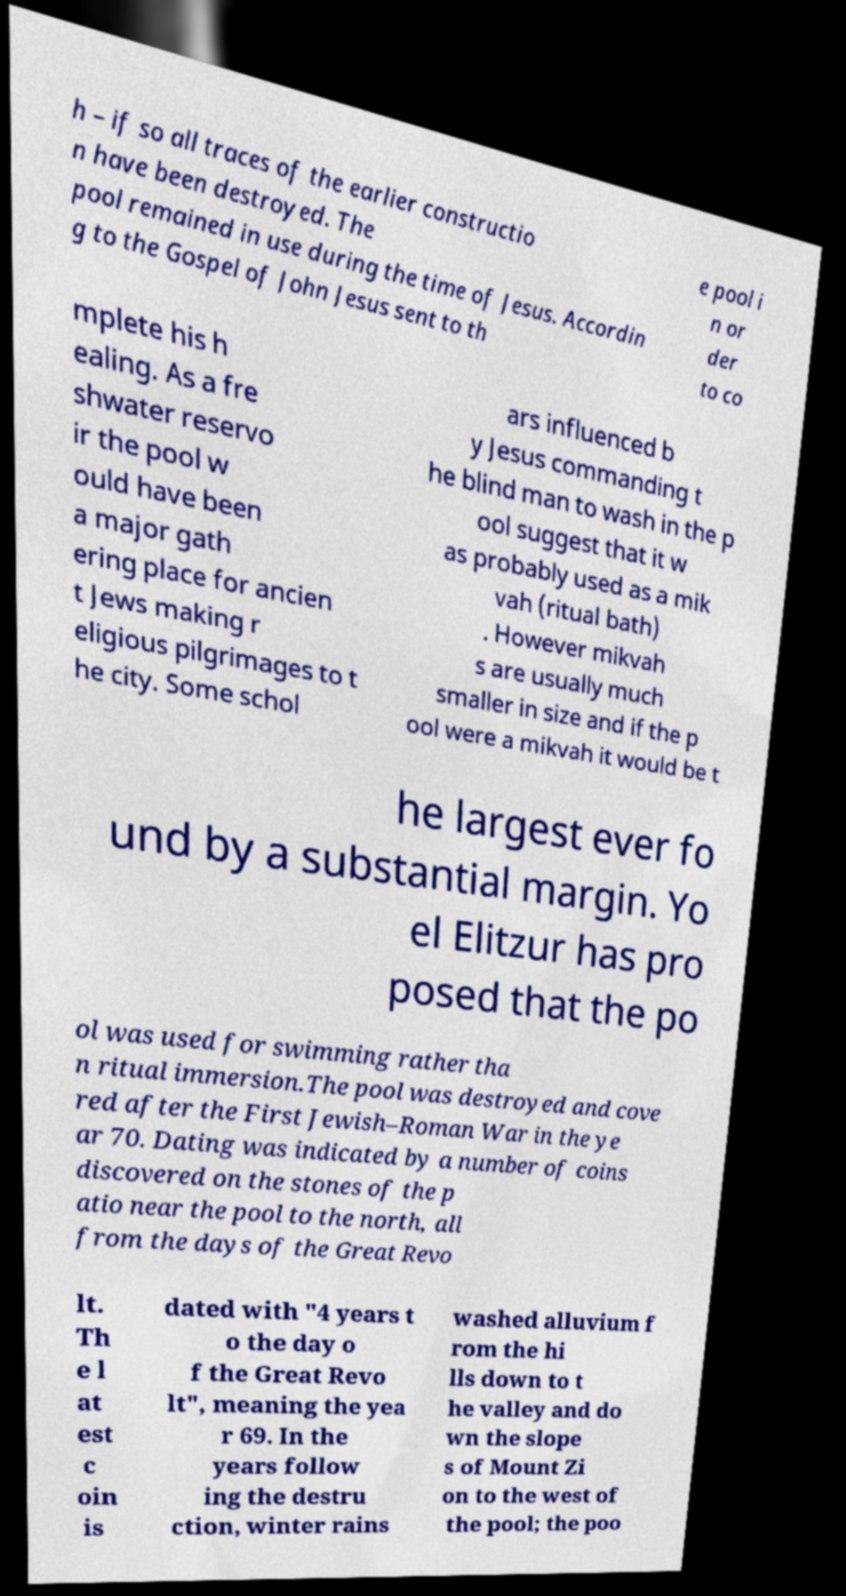I need the written content from this picture converted into text. Can you do that? h – if so all traces of the earlier constructio n have been destroyed. The pool remained in use during the time of Jesus. Accordin g to the Gospel of John Jesus sent to th e pool i n or der to co mplete his h ealing. As a fre shwater reservo ir the pool w ould have been a major gath ering place for ancien t Jews making r eligious pilgrimages to t he city. Some schol ars influenced b y Jesus commanding t he blind man to wash in the p ool suggest that it w as probably used as a mik vah (ritual bath) . However mikvah s are usually much smaller in size and if the p ool were a mikvah it would be t he largest ever fo und by a substantial margin. Yo el Elitzur has pro posed that the po ol was used for swimming rather tha n ritual immersion.The pool was destroyed and cove red after the First Jewish–Roman War in the ye ar 70. Dating was indicated by a number of coins discovered on the stones of the p atio near the pool to the north, all from the days of the Great Revo lt. Th e l at est c oin is dated with "4 years t o the day o f the Great Revo lt", meaning the yea r 69. In the years follow ing the destru ction, winter rains washed alluvium f rom the hi lls down to t he valley and do wn the slope s of Mount Zi on to the west of the pool; the poo 